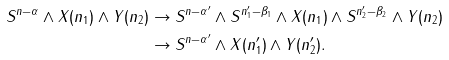<formula> <loc_0><loc_0><loc_500><loc_500>S ^ { n - \alpha } \wedge X ( n _ { 1 } ) \wedge Y ( n _ { 2 } ) & \to S ^ { n - \alpha ^ { \prime } } \wedge S ^ { n _ { 1 } ^ { \prime } - \beta _ { 1 } } \wedge X ( n _ { 1 } ) \wedge S ^ { n _ { 2 } ^ { \prime } - \beta _ { 2 } } \wedge Y ( n _ { 2 } ) \\ & \to S ^ { n - \alpha ^ { \prime } } \wedge X ( n _ { 1 } ^ { \prime } ) \wedge Y ( n _ { 2 } ^ { \prime } ) .</formula> 